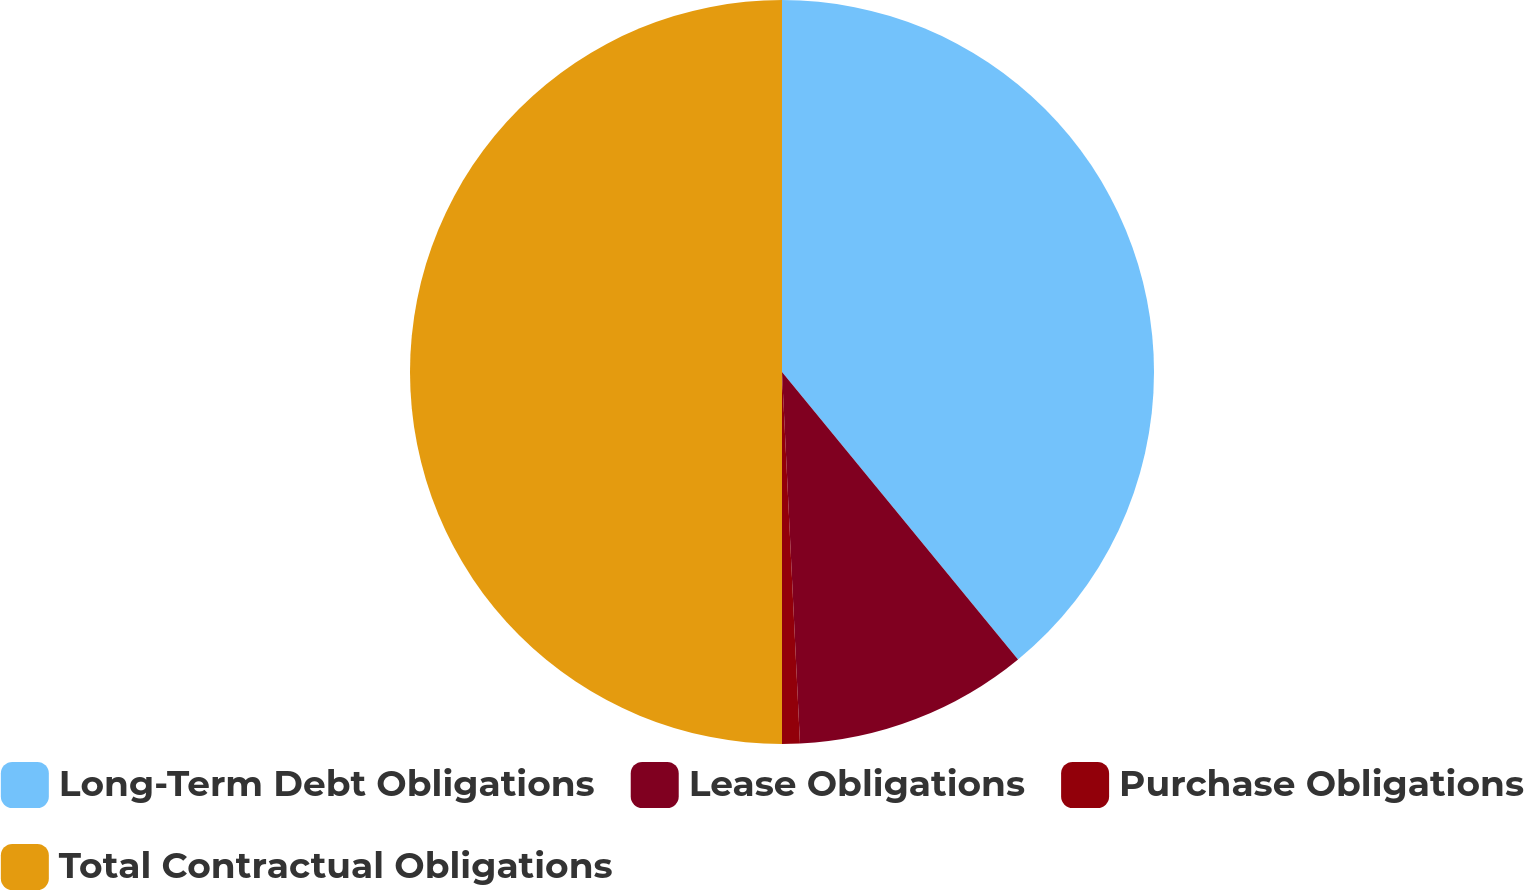Convert chart. <chart><loc_0><loc_0><loc_500><loc_500><pie_chart><fcel>Long-Term Debt Obligations<fcel>Lease Obligations<fcel>Purchase Obligations<fcel>Total Contractual Obligations<nl><fcel>39.06%<fcel>10.17%<fcel>0.77%<fcel>50.0%<nl></chart> 